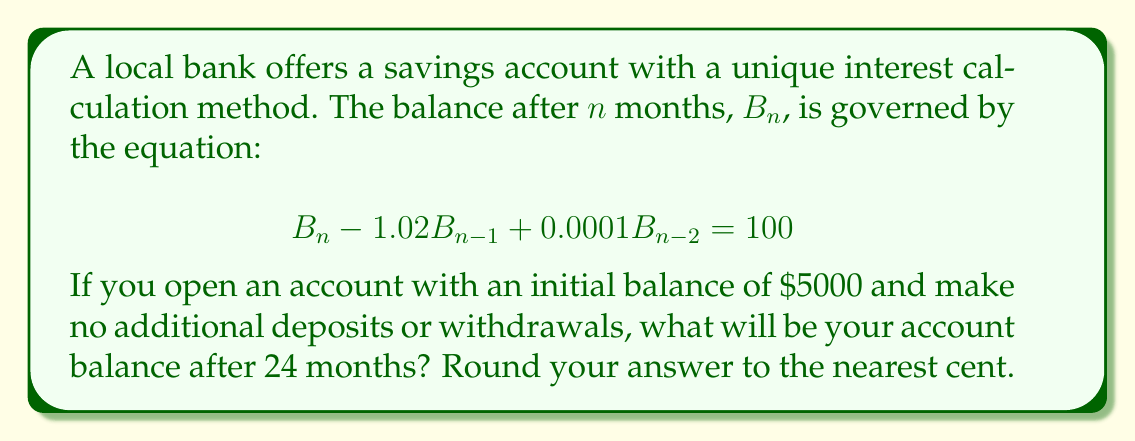Help me with this question. To solve this problem, we need to use the method for solving non-homogeneous second-order linear equations. Let's break it down step by step:

1) The general solution to this equation will be of the form:
   $B_n = B_n^{(h)} + B_n^{(p)}$
   where $B_n^{(h)}$ is the homogeneous solution and $B_n^{(p)}$ is the particular solution.

2) For the homogeneous part, we solve the characteristic equation:
   $r^2 - 1.02r + 0.0001 = 0$
   Using the quadratic formula, we get:
   $r_1 \approx 1.0199$ and $r_2 \approx 0.0001$

3) The homogeneous solution is thus:
   $B_n^{(h)} = c_1(1.0199)^n + c_2(0.0001)^n$

4) For the particular solution, since the right side is constant, we can assume:
   $B_n^{(p)} = A$, where A is a constant.
   Substituting this into the original equation:
   $A - 1.02A + 0.0001A = 100$
   $-0.0199A = 100$
   $A = -5025.13$

5) The general solution is:
   $B_n = c_1(1.0199)^n + c_2(0.0001)^n - 5025.13$

6) To find $c_1$ and $c_2$, we use the initial conditions:
   $B_0 = 5000$ and $B_1 = 1.02B_0 = 5100$

7) Solving the system of equations:
   $5000 = c_1 + c_2 - 5025.13$
   $5100 = 1.0199c_1 + 0.0001c_2 - 5025.13$

8) We get:
   $c_1 \approx 10024.95$ and $c_2 \approx 0.18$

9) Therefore, the balance after $n$ months is:
   $B_n = 10024.95(1.0199)^n + 0.18(0.0001)^n - 5025.13$

10) For $n = 24$:
    $B_{24} = 10024.95(1.0199)^{24} + 0.18(0.0001)^{24} - 5025.13$
    $\approx 7859.87$
Answer: $7859.87 